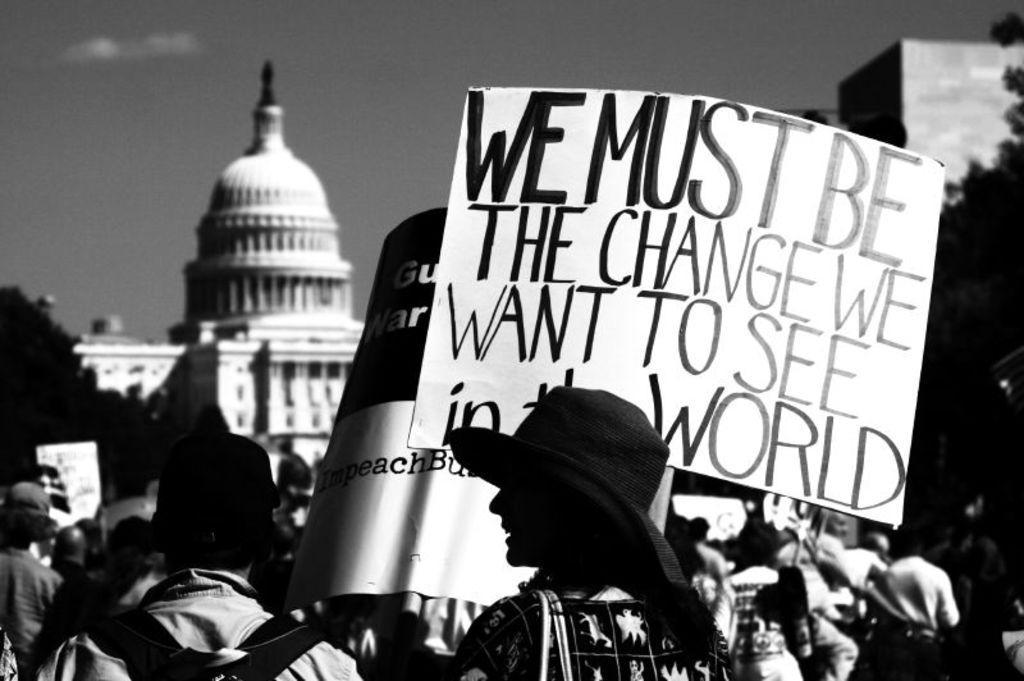Describe this image in one or two sentences. This is a black and white image and here we can see people wearing bags, caps, hats and some are holding boards. In the background, there are trees and we can see buildings. At the top, there is sky. 